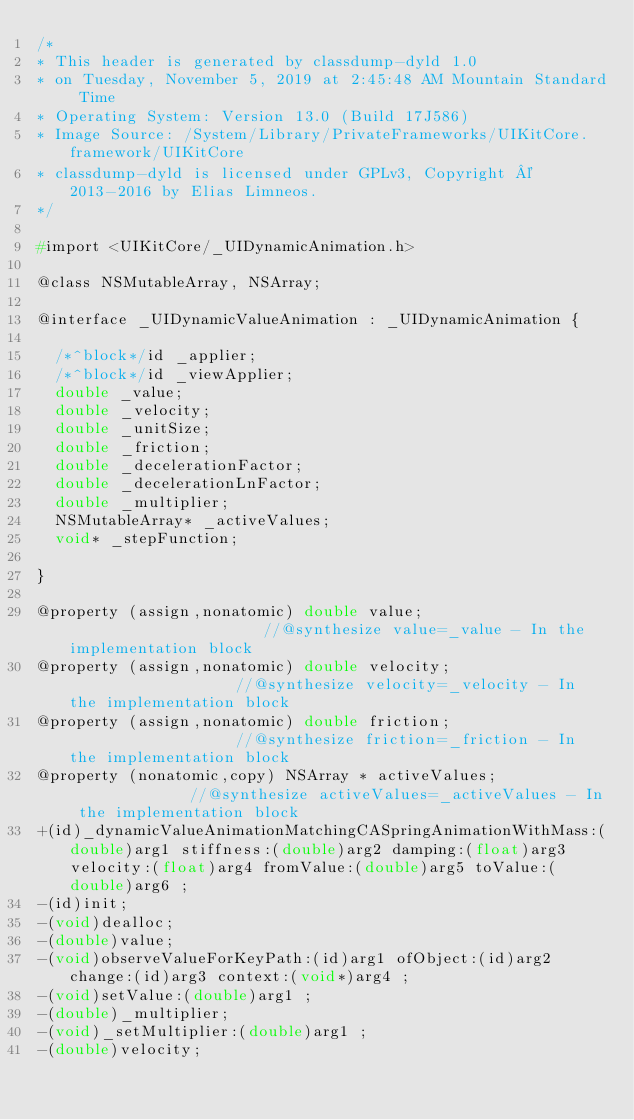Convert code to text. <code><loc_0><loc_0><loc_500><loc_500><_C_>/*
* This header is generated by classdump-dyld 1.0
* on Tuesday, November 5, 2019 at 2:45:48 AM Mountain Standard Time
* Operating System: Version 13.0 (Build 17J586)
* Image Source: /System/Library/PrivateFrameworks/UIKitCore.framework/UIKitCore
* classdump-dyld is licensed under GPLv3, Copyright © 2013-2016 by Elias Limneos.
*/

#import <UIKitCore/_UIDynamicAnimation.h>

@class NSMutableArray, NSArray;

@interface _UIDynamicValueAnimation : _UIDynamicAnimation {

	/*^block*/id _applier;
	/*^block*/id _viewApplier;
	double _value;
	double _velocity;
	double _unitSize;
	double _friction;
	double _decelerationFactor;
	double _decelerationLnFactor;
	double _multiplier;
	NSMutableArray* _activeValues;
	void* _stepFunction;

}

@property (assign,nonatomic) double value;                      //@synthesize value=_value - In the implementation block
@property (assign,nonatomic) double velocity;                   //@synthesize velocity=_velocity - In the implementation block
@property (assign,nonatomic) double friction;                   //@synthesize friction=_friction - In the implementation block
@property (nonatomic,copy) NSArray * activeValues;              //@synthesize activeValues=_activeValues - In the implementation block
+(id)_dynamicValueAnimationMatchingCASpringAnimationWithMass:(double)arg1 stiffness:(double)arg2 damping:(float)arg3 velocity:(float)arg4 fromValue:(double)arg5 toValue:(double)arg6 ;
-(id)init;
-(void)dealloc;
-(double)value;
-(void)observeValueForKeyPath:(id)arg1 ofObject:(id)arg2 change:(id)arg3 context:(void*)arg4 ;
-(void)setValue:(double)arg1 ;
-(double)_multiplier;
-(void)_setMultiplier:(double)arg1 ;
-(double)velocity;</code> 